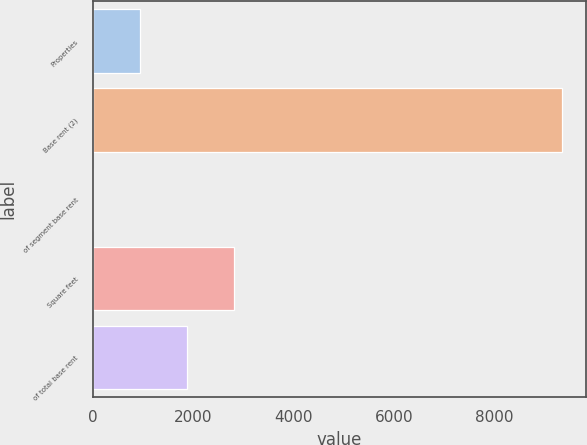Convert chart to OTSL. <chart><loc_0><loc_0><loc_500><loc_500><bar_chart><fcel>Properties<fcel>Base rent (2)<fcel>of segment base rent<fcel>Square feet<fcel>of total base rent<nl><fcel>939<fcel>9354<fcel>4<fcel>2809<fcel>1874<nl></chart> 